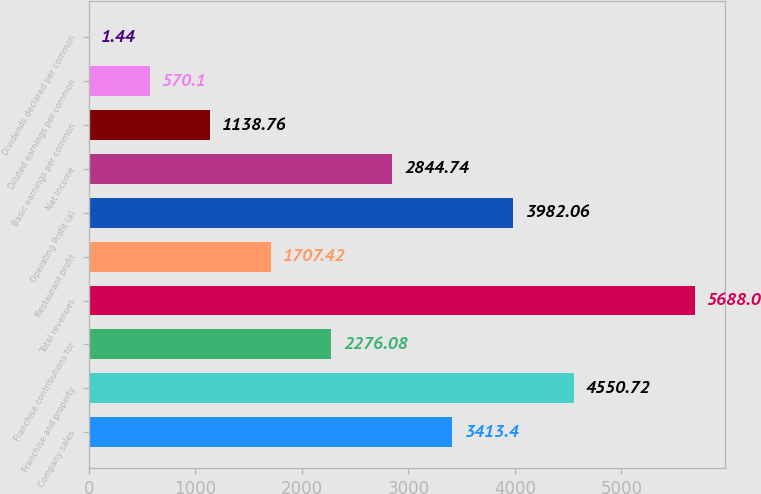Convert chart. <chart><loc_0><loc_0><loc_500><loc_500><bar_chart><fcel>Company sales<fcel>Franchise and property<fcel>Franchise contributions for<fcel>Total revenues<fcel>Restaurant profit<fcel>Operating Profit (a)<fcel>Net Income<fcel>Basic earnings per common<fcel>Diluted earnings per common<fcel>Dividends declared per common<nl><fcel>3413.4<fcel>4550.72<fcel>2276.08<fcel>5688<fcel>1707.42<fcel>3982.06<fcel>2844.74<fcel>1138.76<fcel>570.1<fcel>1.44<nl></chart> 